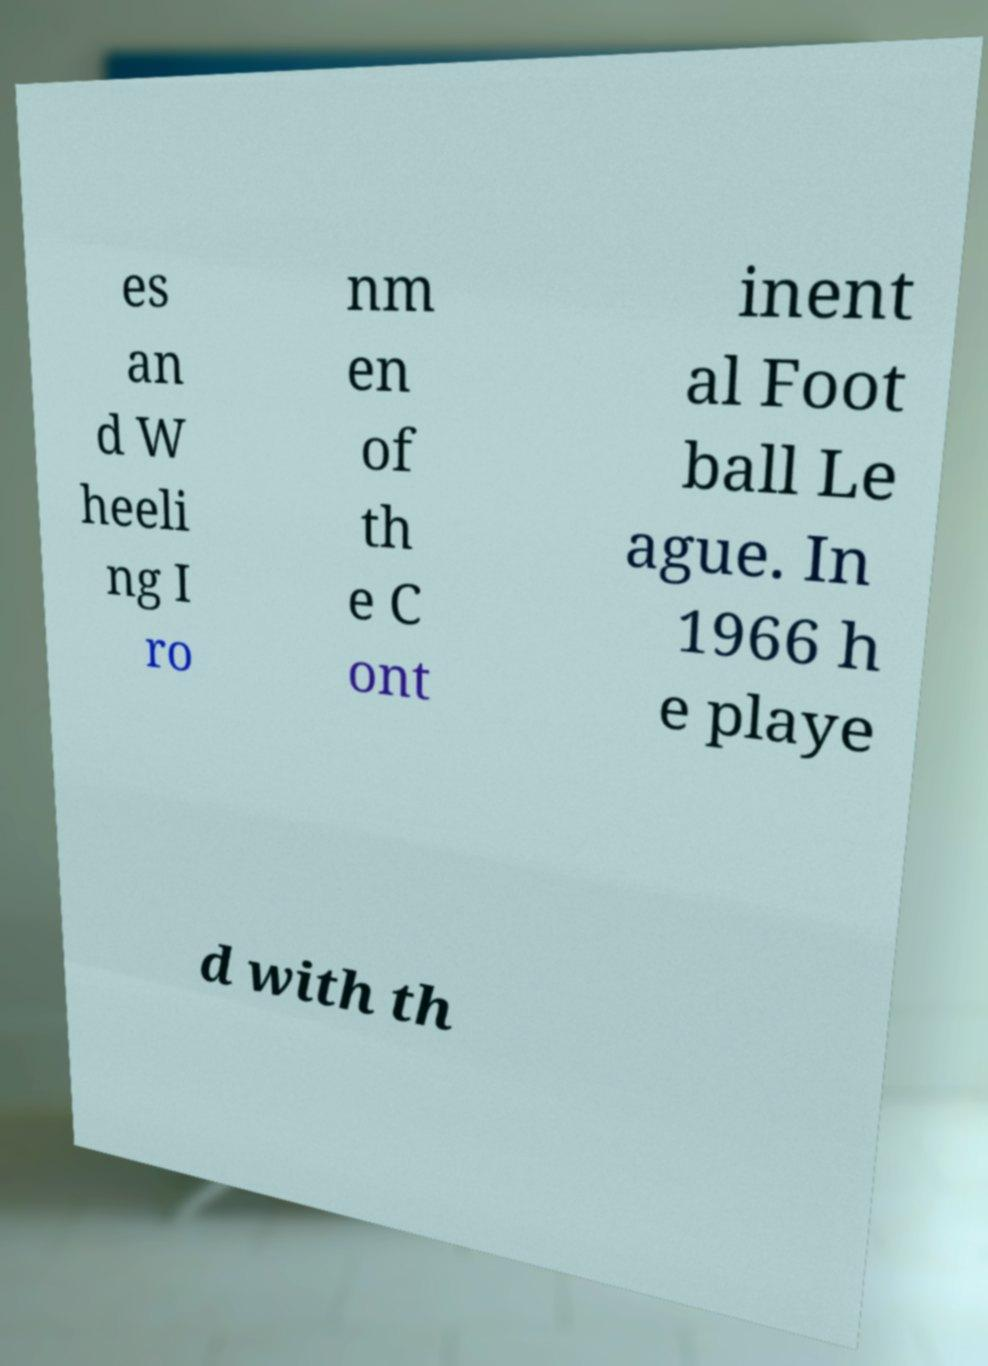Could you assist in decoding the text presented in this image and type it out clearly? es an d W heeli ng I ro nm en of th e C ont inent al Foot ball Le ague. In 1966 h e playe d with th 